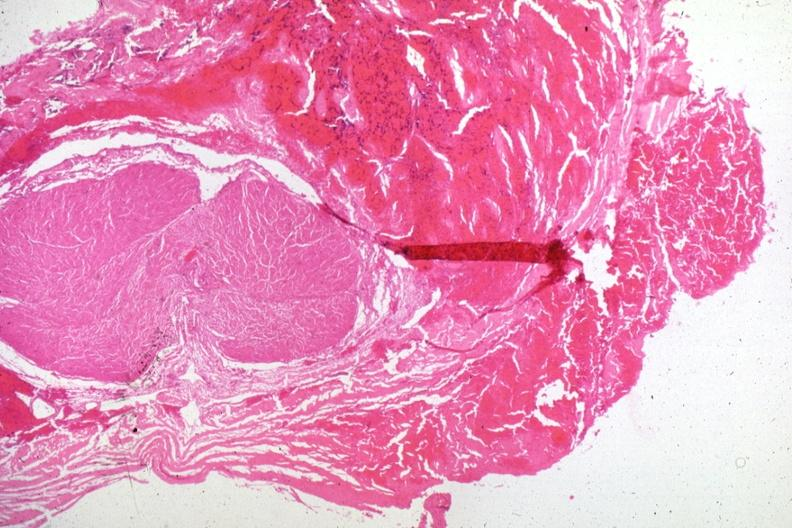where is this part in the figure?
Answer the question using a single word or phrase. Endocrine system 